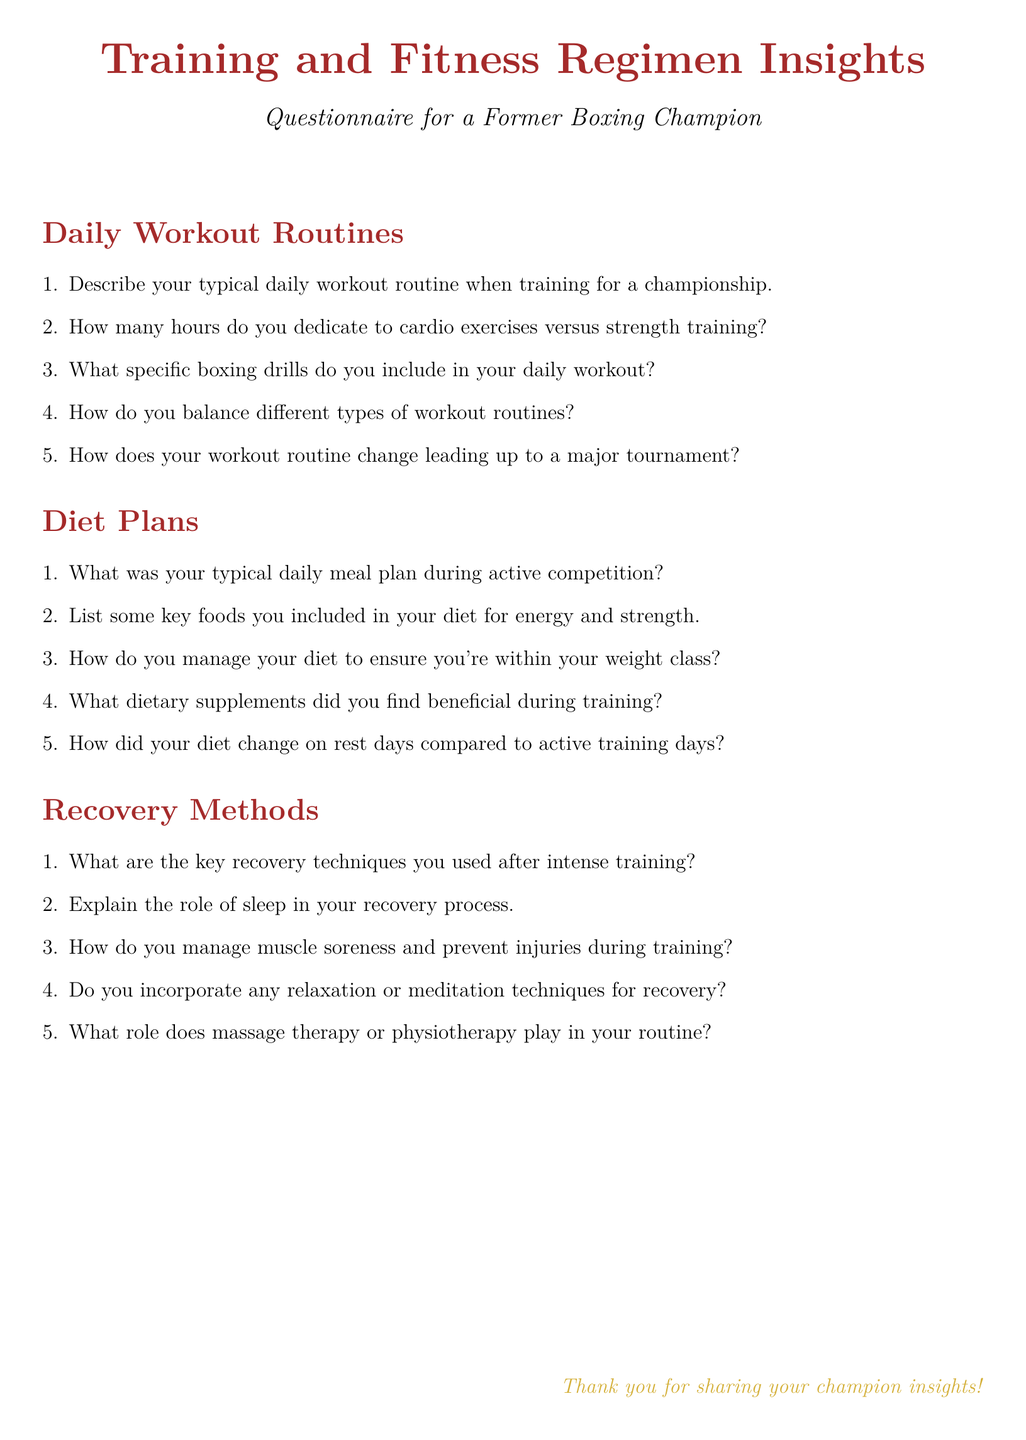What is the title of the document? The title is prominently displayed at the beginning of the document, stating the focus of the questionnaire.
Answer: Training and Fitness Regimen Insights Who is the intended respondent of the questionnaire? The document specifies that it is designed for a specific group, indicating the target audience.
Answer: Former Boxing Champion How many sections are in the questionnaire? The document contains different sections, which can be counted to determine the total number.
Answer: 3 What is one of the recovery methods mentioned in the document? The document lists various methods under the recovery section, prompting a recall of one of them.
Answer: Massage therapy Which color is used for section titles? The document uses a specific color for section headings, identifiable at first glance.
Answer: Boxingred How does the daily meal plan change on rest days? This review question requires understanding the differences between training and rest days as mentioned in the document.
Answer: Compared to active training days What type of questions are included in the document? The structure of the document reveals the nature of the questions it includes.
Answer: Short-answer questions How many hours are dedicated to cardio versus strength training? The document asks for specific numerical comparisons related to workout routines.
Answer: Inquiring about hours dedicated What is said about sleep in the recovery process? This question looks for insights on what is emphasized about sleep from the document's perspective.
Answer: Role of sleep in recovery 